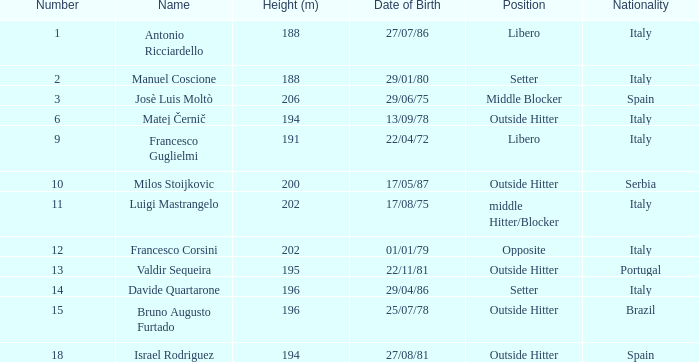Which country does francesco guglielmi come from? Italy. Parse the table in full. {'header': ['Number', 'Name', 'Height (m)', 'Date of Birth', 'Position', 'Nationality'], 'rows': [['1', 'Antonio Ricciardello', '188', '27/07/86', 'Libero', 'Italy'], ['2', 'Manuel Coscione', '188', '29/01/80', 'Setter', 'Italy'], ['3', 'Josè Luis Moltò', '206', '29/06/75', 'Middle Blocker', 'Spain'], ['6', 'Matej Černič', '194', '13/09/78', 'Outside Hitter', 'Italy'], ['9', 'Francesco Guglielmi', '191', '22/04/72', 'Libero', 'Italy'], ['10', 'Milos Stoijkovic', '200', '17/05/87', 'Outside Hitter', 'Serbia'], ['11', 'Luigi Mastrangelo', '202', '17/08/75', 'middle Hitter/Blocker', 'Italy'], ['12', 'Francesco Corsini', '202', '01/01/79', 'Opposite', 'Italy'], ['13', 'Valdir Sequeira', '195', '22/11/81', 'Outside Hitter', 'Portugal'], ['14', 'Davide Quartarone', '196', '29/04/86', 'Setter', 'Italy'], ['15', 'Bruno Augusto Furtado', '196', '25/07/78', 'Outside Hitter', 'Brazil'], ['18', 'Israel Rodriguez', '194', '27/08/81', 'Outside Hitter', 'Spain']]} 